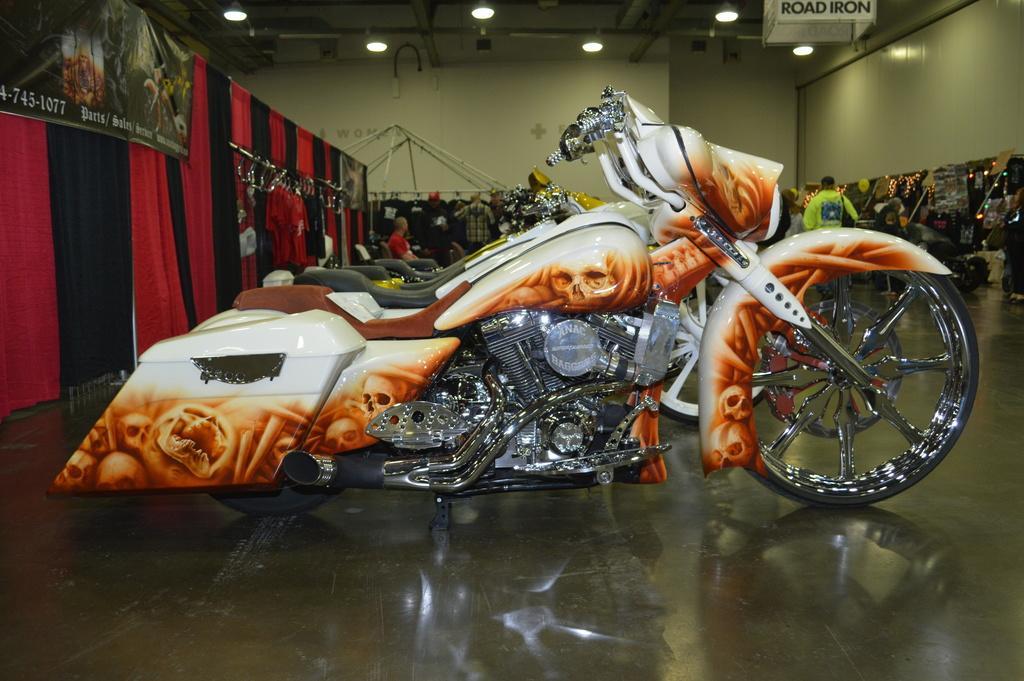Can you describe this image briefly? In this image we can see bikes are showcased and kept on the floor, here we can see the banners, curtains, a few people standing here, jackets hanged here, we can see boards and lights in the ceiling. 